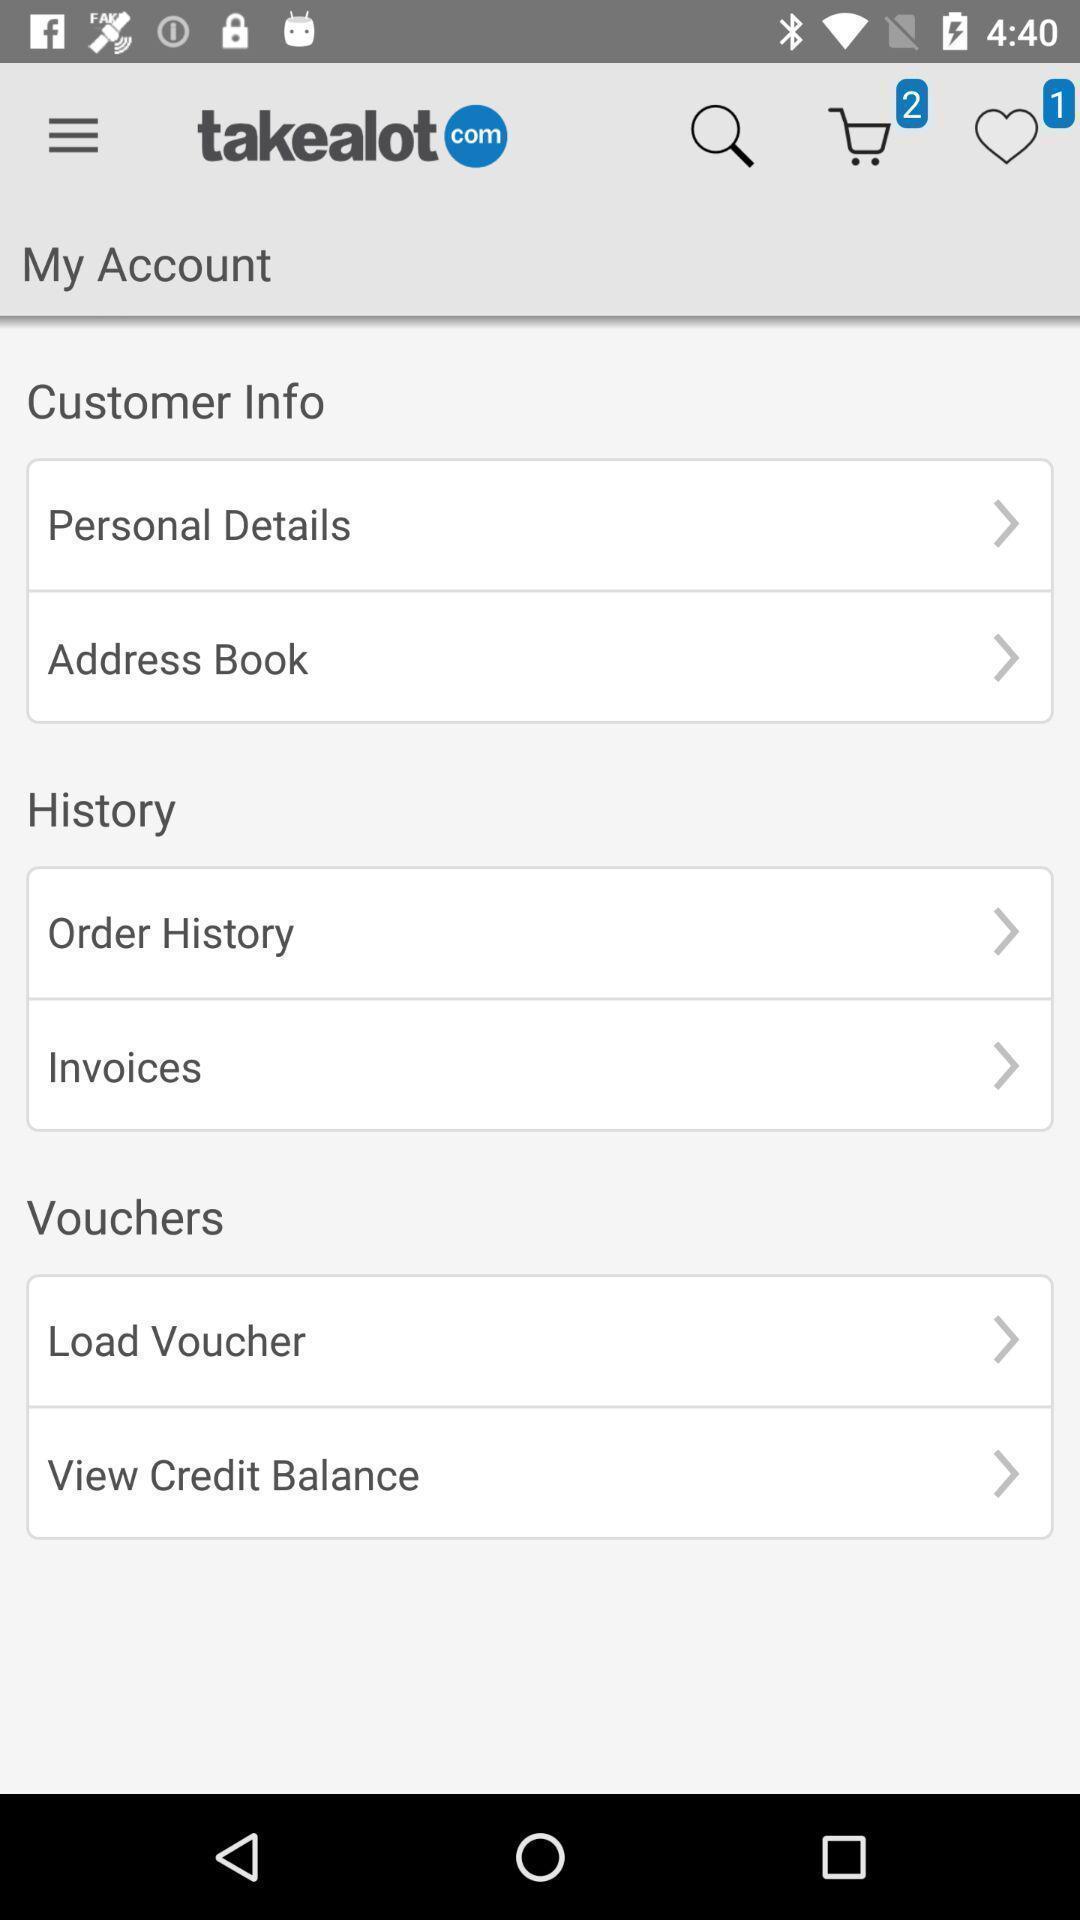Describe this image in words. Screen shows customer info in a shopping app. 